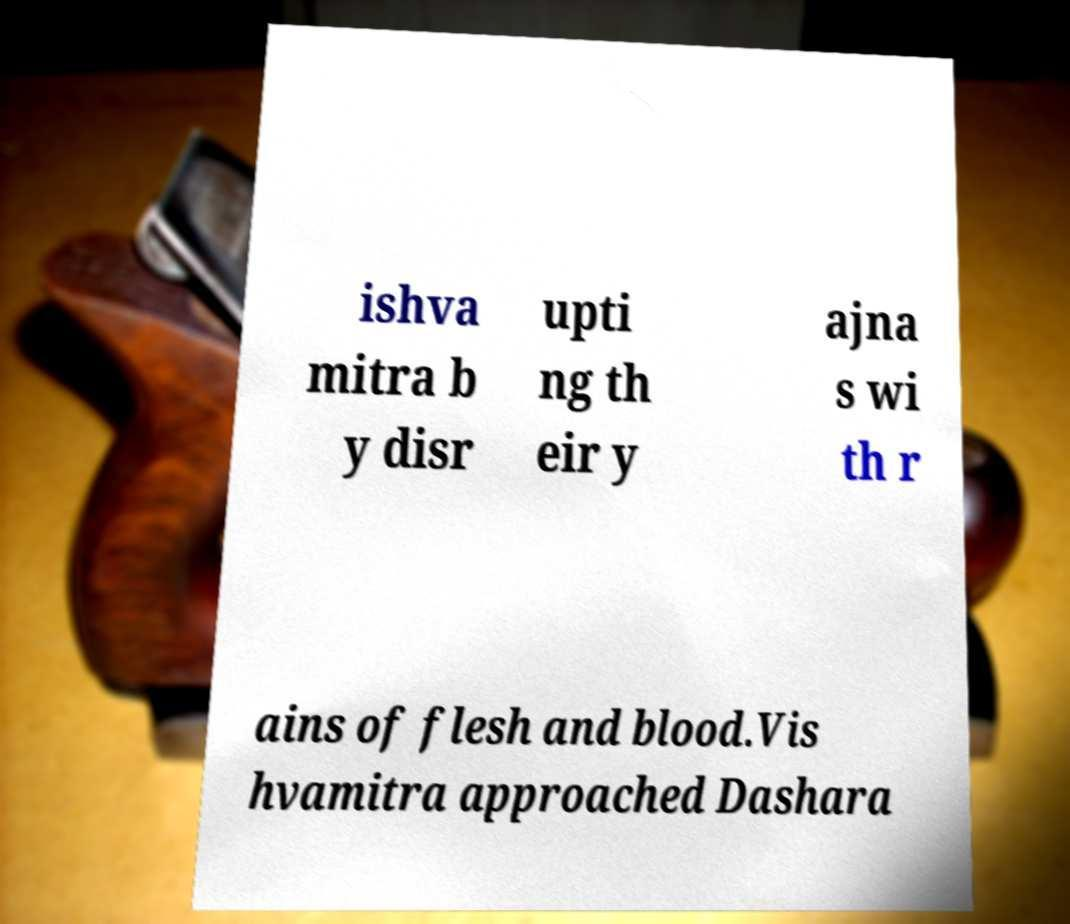I need the written content from this picture converted into text. Can you do that? ishva mitra b y disr upti ng th eir y ajna s wi th r ains of flesh and blood.Vis hvamitra approached Dashara 